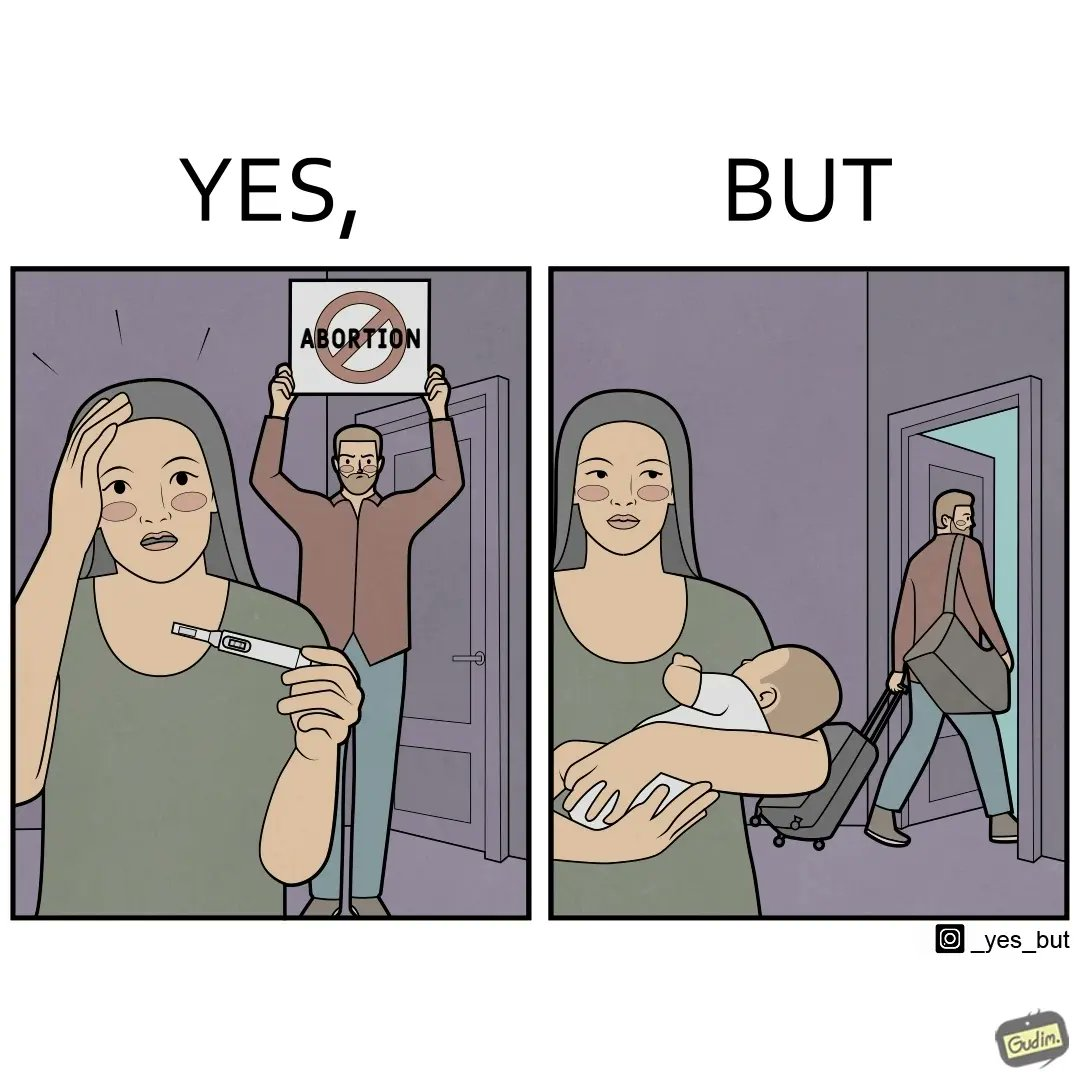Explain the humor or irony in this image. The images are ironic, since they show how men protest against abortion of babies but they choose to leave instead of taking care of the babies once they are born leaving the mother with neither a choice or support for raising a child 